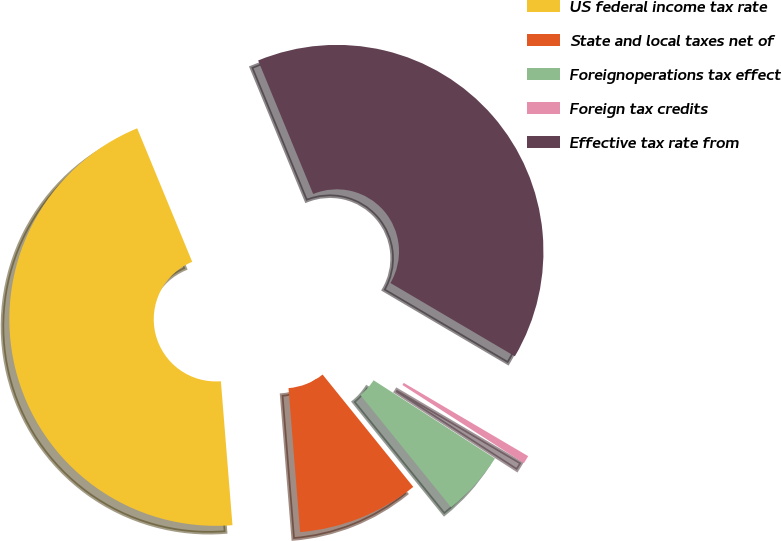Convert chart to OTSL. <chart><loc_0><loc_0><loc_500><loc_500><pie_chart><fcel>US federal income tax rate<fcel>State and local taxes net of<fcel>Foreignoperations tax effect<fcel>Foreign tax credits<fcel>Effective tax rate from<nl><fcel>45.05%<fcel>9.53%<fcel>5.08%<fcel>0.64%<fcel>39.69%<nl></chart> 